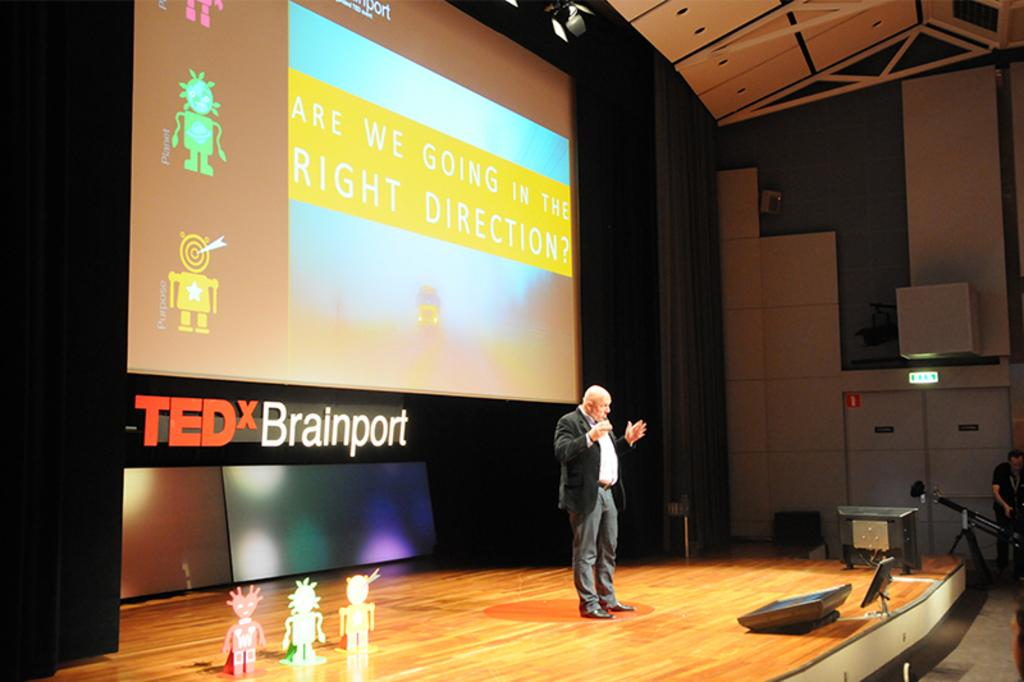<image>
Share a concise interpretation of the image provided. A man stands on stage in front of a projection screen that asks "Are we going in the right direction?". 